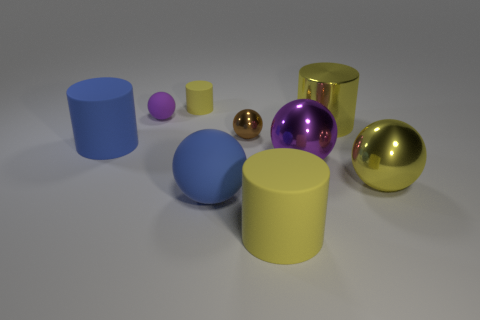There is another purple object that is the same shape as the large purple metal object; what is it made of? The smaller purple object appears to be made of a matte material, possibly plastic or a type of non-reflective rubber. It shares the same spherical shape as the larger purple object, which looks metallic and reflective, showcasing a contrast in materials despite the similarity in color and shape. 